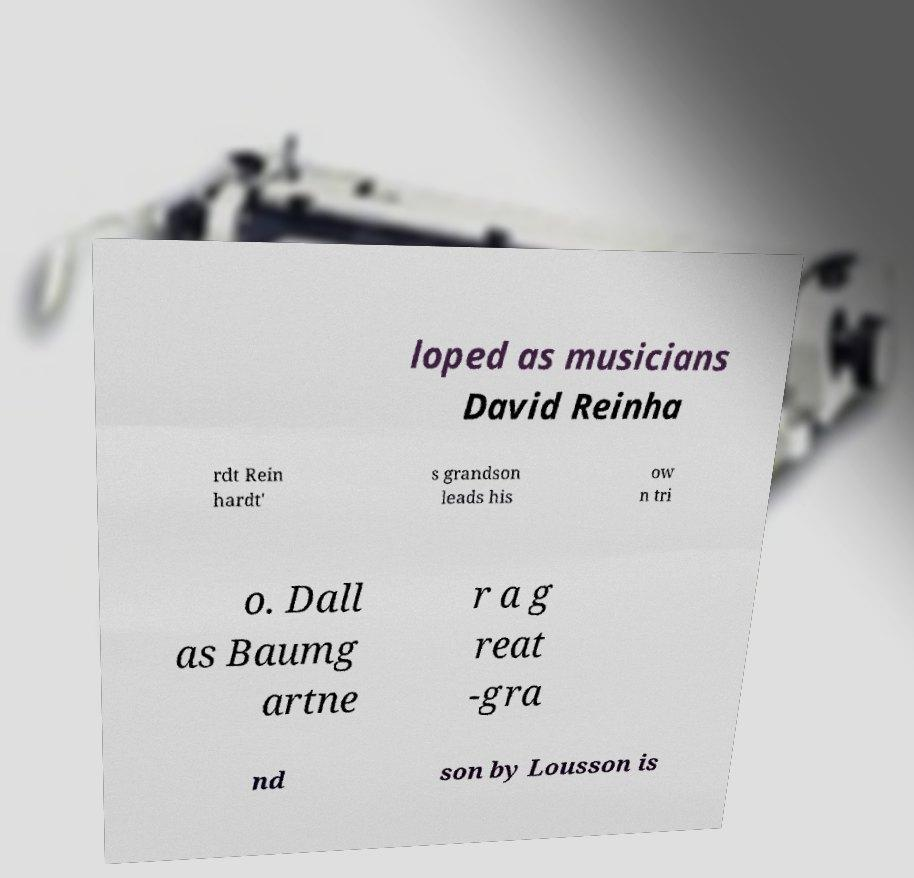Can you read and provide the text displayed in the image?This photo seems to have some interesting text. Can you extract and type it out for me? loped as musicians David Reinha rdt Rein hardt' s grandson leads his ow n tri o. Dall as Baumg artne r a g reat -gra nd son by Lousson is 